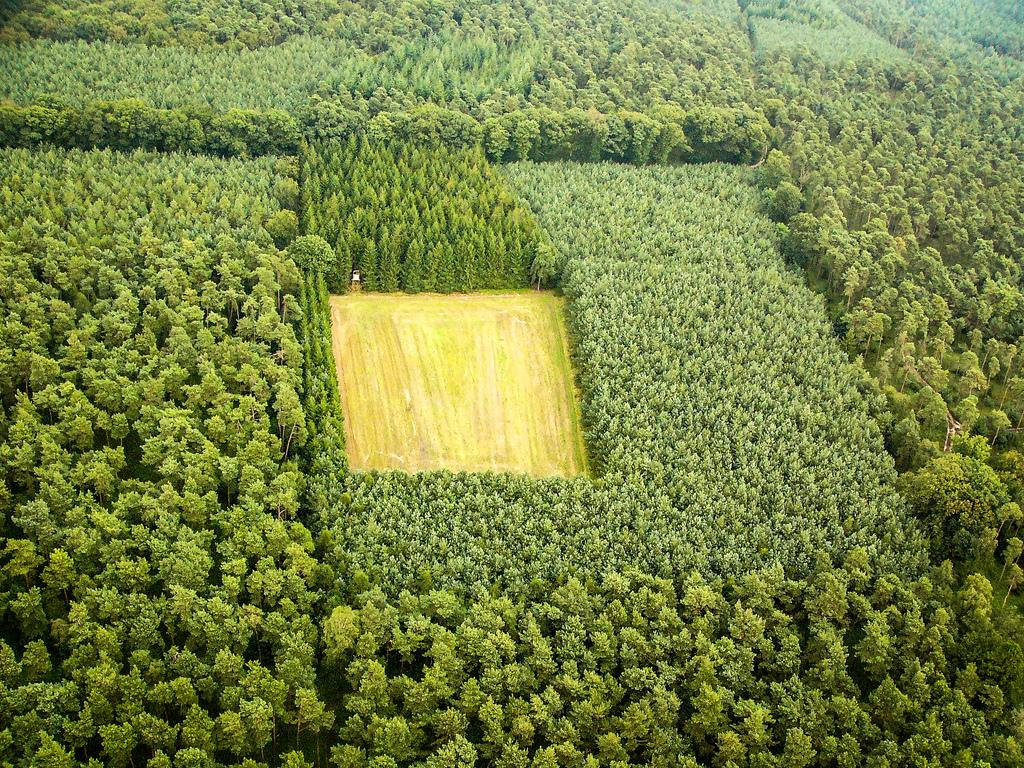What type of vegetation can be seen in the image? There are green color trees in the image. What else is visible in the image besides the trees? The ground is visible in the image. How many fingers can be seen holding a cherry in the image? There are no fingers or cherries present in the image; it only features green color trees and the ground. 